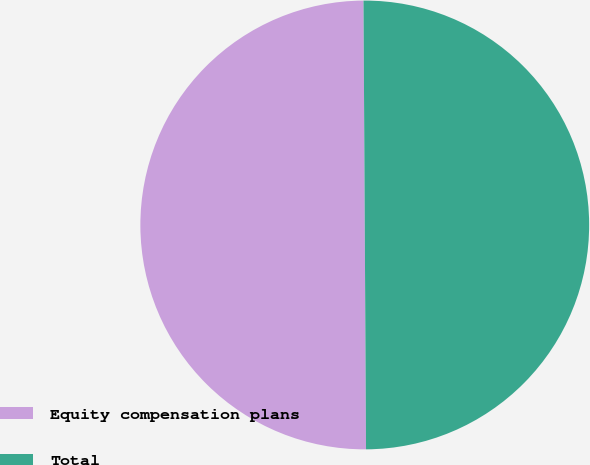<chart> <loc_0><loc_0><loc_500><loc_500><pie_chart><fcel>Equity compensation plans<fcel>Total<nl><fcel>50.0%<fcel>50.0%<nl></chart> 